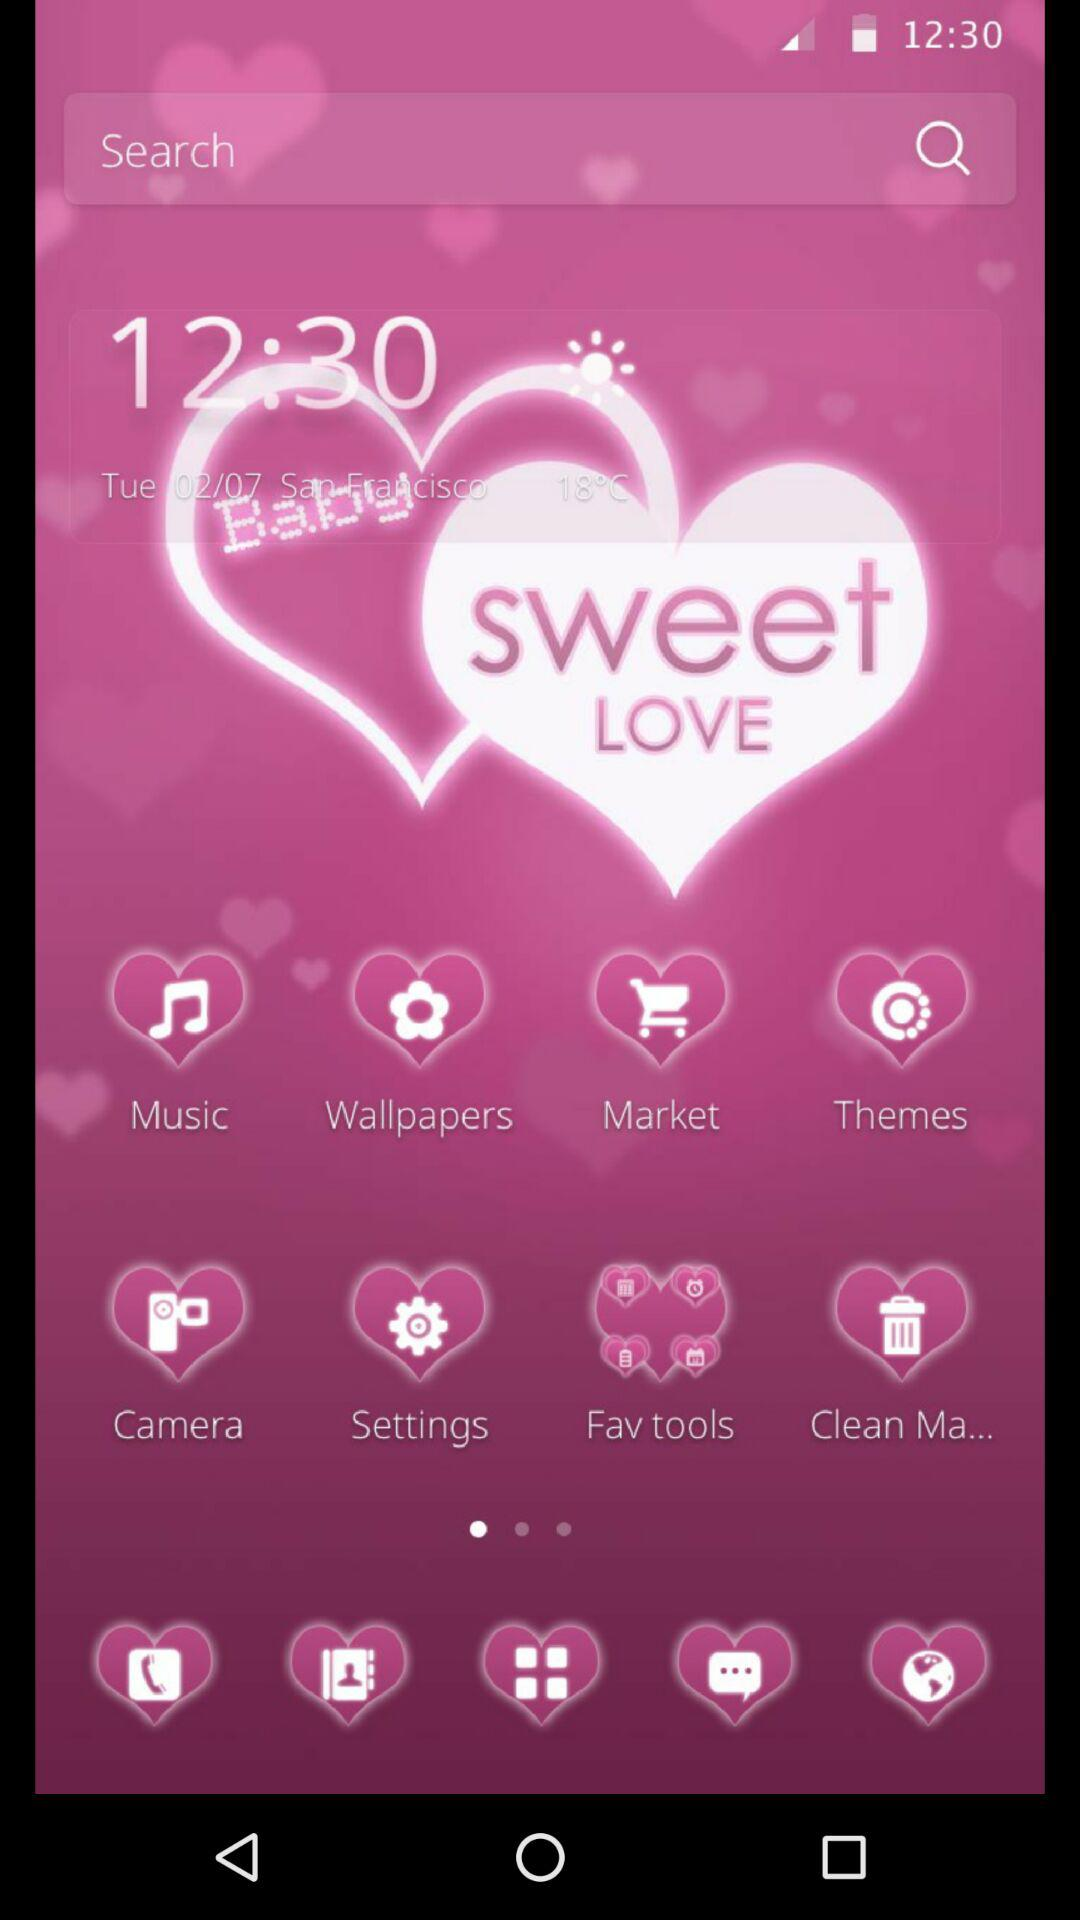What is the time? The time is 12:30. 